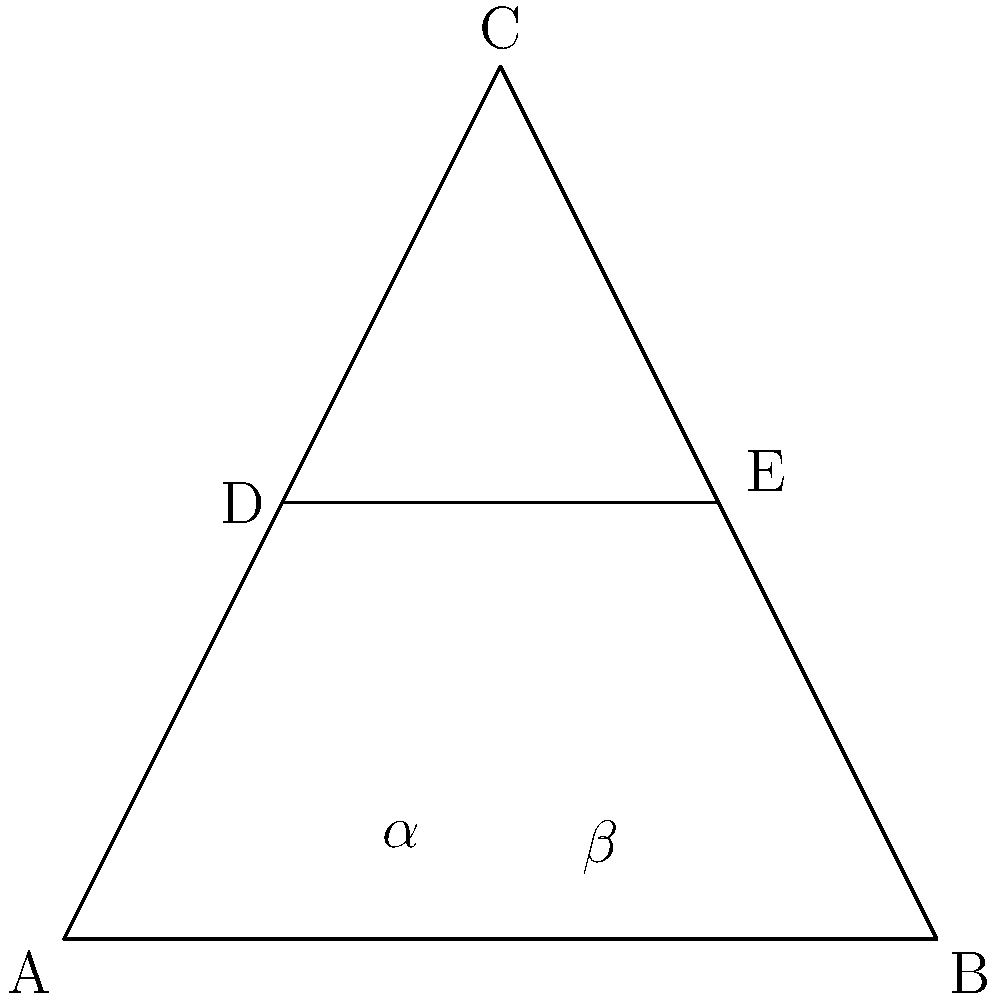In your latest film, you've incorporated a striking image of a Greek cross. If the vertical beam of the cross divides the base of the triangle ABC into two equal parts, and angle C is 90°, what is the measure of angle $\alpha$ in terms of angle $\beta$? Let's approach this step-by-step:

1) First, note that triangle ABC is a right-angled triangle with the right angle at C.

2) The vertical beam DE divides the base AB into two equal parts. This means AD = DB.

3) In a right-angled triangle, the altitude to the hypotenuse divides the triangle into two similar triangles. Here, DE is the altitude to the hypotenuse AB.

4) Due to the similarity of triangles ADE and CDE:
   $$\frac{AD}{CD} = \frac{CD}{BD}$$

5) As AD = DB (from step 2), we can say that triangles ADE and BDE are congruent.

6) This congruence means that angle $\alpha$ in triangle ADE is equal to angle $\beta$ in triangle BDE.

7) In triangle ABC:
   $$\alpha + \beta + 90° = 180°$$
   (sum of angles in a triangle)

8) As $\alpha = \beta$ (from step 6), we can replace $\beta$ with $\alpha$ in the equation:
   $$\alpha + \alpha + 90° = 180°$$
   $$2\alpha + 90° = 180°$$
   $$2\alpha = 90°$$
   $$\alpha = 45°$$

9) Therefore, $\alpha = \beta = 45°$

10) To express $\alpha$ in terms of $\beta$, we can simply say:
    $$\alpha = \beta$$
Answer: $\alpha = \beta$ 